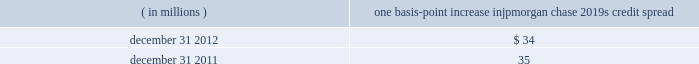Jpmorgan chase & co./2012 annual report 167 the chart shows that for year ended december 31 , 2012 , the firm posted market risk related gains on 220 of the 261 days in this period , with gains on eight days exceeding $ 200 million .
The chart includes year to date losses incurred in the synthetic credit portfolio .
Cib and credit portfolio posted market risk-related gains on 254 days in the period .
The inset graph looks at those days on which the firm experienced losses and depicts the amount by which var exceeded the actual loss on each of those days .
Of the losses that were sustained on the 41 days of the 261 days in the trading period , the firm sustained losses that exceeded the var measure on three of those days .
These losses in excess of the var all occurred in the second quarter of 2012 and were due to the adverse effect of market movements on risk positions in the synthetic credit portfolio held by cio .
During the year ended december 31 , 2012 , cib and credit portfolio experienced seven loss days ; none of the losses on those days exceeded their respective var measures .
Other risk measures debit valuation adjustment sensitivity the table provides information about the gross sensitivity of dva to a one-basis-point increase in jpmorgan chase 2019s credit spreads .
This sensitivity represents the impact from a one-basis-point parallel shift in jpmorgan chase 2019s entire credit curve .
However , the sensitivity at a single point in time multiplied by the change in credit spread at a single maturity point may not be representative of the actual dva gain or loss realized within a period .
The actual results reflect the movement in credit spreads across various maturities , which typically do not move in a parallel fashion , and is the product of a constantly changing exposure profile , among other factors .
Debit valuation adjustment sensitivity ( in millions ) one basis-point increase in jpmorgan chase 2019s credit spread .
Economic-value stress testing along with var , stress testing is important in measuring and controlling risk .
While var reflects the risk of loss due to adverse changes in markets using recent historical market behavior as an indicator of losses , stress testing captures the firm 2019s exposure to unlikely but plausible events in abnormal markets .
The firm runs weekly stress tests on market-related risks across the lines of business using multiple scenarios that assume significant changes in risk factors such as credit spreads , equity prices , interest rates , currency rates or commodity prices .
The framework uses a grid-based approach , which calculates multiple magnitudes of stress for both market rallies and market sell-offs for .
How often did the firm post gains exceeding $ 200 million in 2012?\\n? 
Computations: (8 / 261)
Answer: 0.03065. Jpmorgan chase & co./2012 annual report 167 the chart shows that for year ended december 31 , 2012 , the firm posted market risk related gains on 220 of the 261 days in this period , with gains on eight days exceeding $ 200 million .
The chart includes year to date losses incurred in the synthetic credit portfolio .
Cib and credit portfolio posted market risk-related gains on 254 days in the period .
The inset graph looks at those days on which the firm experienced losses and depicts the amount by which var exceeded the actual loss on each of those days .
Of the losses that were sustained on the 41 days of the 261 days in the trading period , the firm sustained losses that exceeded the var measure on three of those days .
These losses in excess of the var all occurred in the second quarter of 2012 and were due to the adverse effect of market movements on risk positions in the synthetic credit portfolio held by cio .
During the year ended december 31 , 2012 , cib and credit portfolio experienced seven loss days ; none of the losses on those days exceeded their respective var measures .
Other risk measures debit valuation adjustment sensitivity the table provides information about the gross sensitivity of dva to a one-basis-point increase in jpmorgan chase 2019s credit spreads .
This sensitivity represents the impact from a one-basis-point parallel shift in jpmorgan chase 2019s entire credit curve .
However , the sensitivity at a single point in time multiplied by the change in credit spread at a single maturity point may not be representative of the actual dva gain or loss realized within a period .
The actual results reflect the movement in credit spreads across various maturities , which typically do not move in a parallel fashion , and is the product of a constantly changing exposure profile , among other factors .
Debit valuation adjustment sensitivity ( in millions ) one basis-point increase in jpmorgan chase 2019s credit spread .
Economic-value stress testing along with var , stress testing is important in measuring and controlling risk .
While var reflects the risk of loss due to adverse changes in markets using recent historical market behavior as an indicator of losses , stress testing captures the firm 2019s exposure to unlikely but plausible events in abnormal markets .
The firm runs weekly stress tests on market-related risks across the lines of business using multiple scenarios that assume significant changes in risk factors such as credit spreads , equity prices , interest rates , currency rates or commodity prices .
The framework uses a grid-based approach , which calculates multiple magnitudes of stress for both market rallies and market sell-offs for .
What was the percentage change in the one basis-point increase in jpmorgan chase 2019s credit spread from 2011 to 2012? 
Computations: ((35 - 34) / 34)
Answer: 0.02941. 